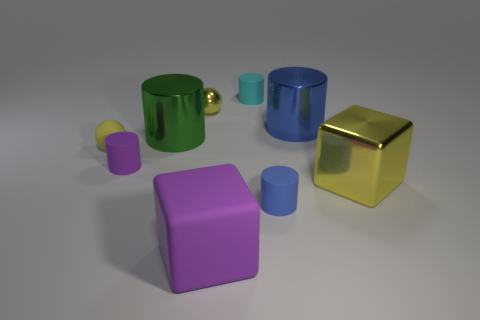Can you describe the lighting conditions in the scene? The lighting in the scene seems to be diffuse and soft, likely coming from an omnidirectional source above the objects. This is indicated by the soft shadows cast directly under the objects and the mild reflections on their surfaces, which suggest an evenly lit environment without harsh direct light sources. 